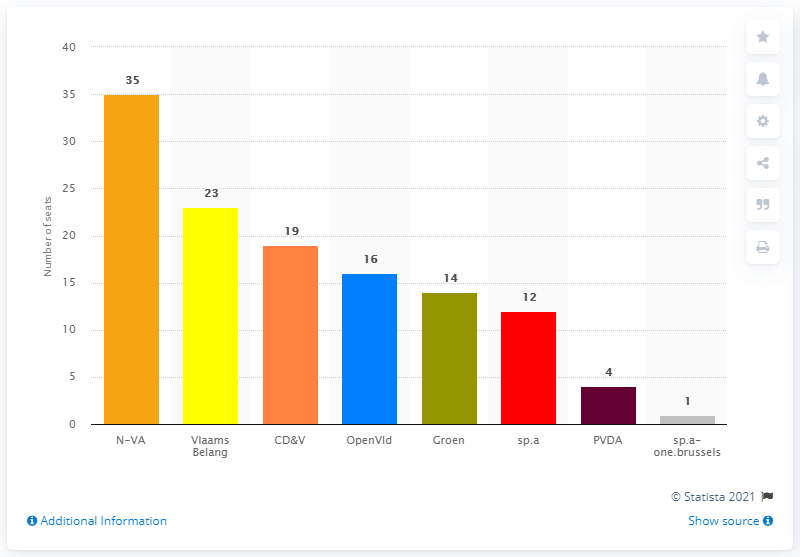Identify some key points in this picture. The New Flemish Alliance (N-VA) obtained 35 seats in the election. The Flemish Parliament has elected Vlaams Belang as the party with the most seats in the recent election. 